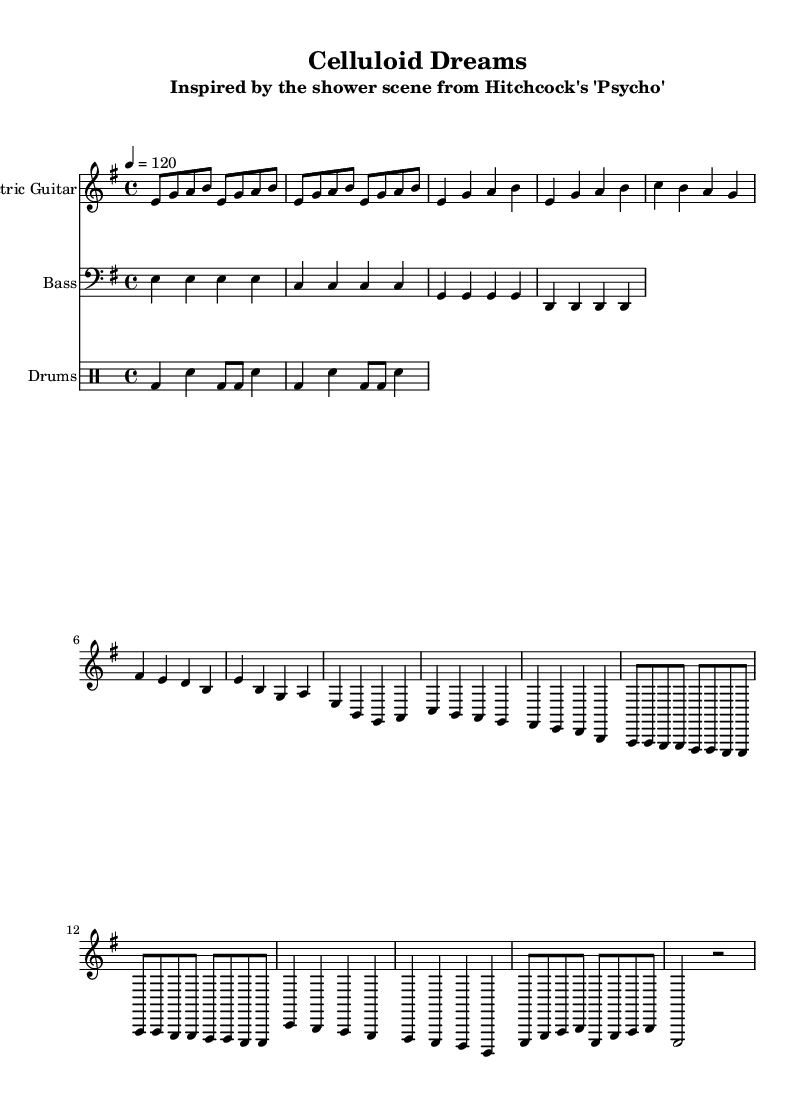What is the key signature of this music? The key signature is E minor, which has one sharp (F#). This is confirmed by checking the left side of the staff, where the sharp is indicated.
Answer: E minor What is the time signature of this piece? The time signature is 4/4, which means there are four beats in a measure and a quarter note receives one beat. This can be identified at the beginning of the score just after the key signature.
Answer: 4/4 What is the tempo marking indicated in the score? The tempo marking is indicated as 120 beats per minute. This is found at the top part of the sheet music, showing a tempo of 4 equals 120.
Answer: 120 beats per minute How many measures are there in the electric guitar part? There are a total of 12 measures in the electric guitar part. By counting the measure bars that divide the staff, we can count each full measure.
Answer: 12 measures What type of instrument is indicated for the staff labeled "Electric Guitar"? The staff labeled "Electric Guitar" indicates that the instrument is an electric guitar, as specified under the instrument name given at the beginning of that staff.
Answer: Electric guitar Which section of the piece contains the chord progression? The bass guitar part contains the chord progression, as it provides underlying harmonies that support the melody. Each measure showcases a distinct chord that aligns with the structure of the song.
Answer: Bass guitar part What rhythmic pattern is used in the drums part? The rhythmic pattern used in the drums part is a basic rock beat, which is characterized by the bass drum and snare drum interplay illustrated with quarter notes and eighth notes.
Answer: Basic rock beat 